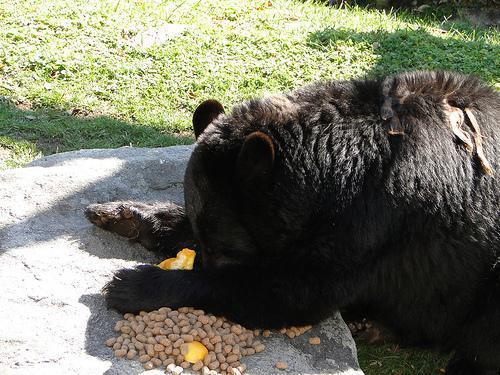How many bears are there?
Give a very brief answer. 1. 